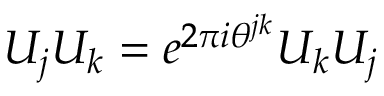<formula> <loc_0><loc_0><loc_500><loc_500>U _ { j } U _ { k } = e ^ { 2 \pi i \theta ^ { j k } } U _ { k } U _ { j }</formula> 